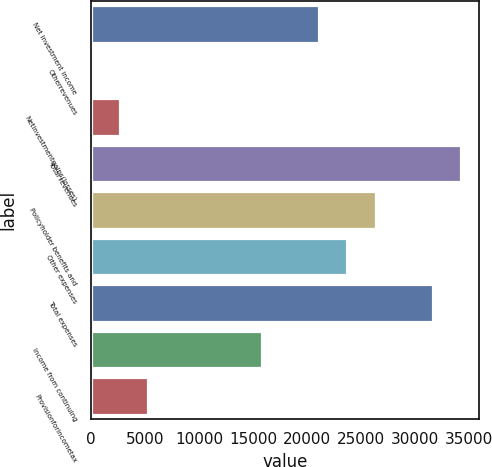Convert chart to OTSL. <chart><loc_0><loc_0><loc_500><loc_500><bar_chart><fcel>Net investment income<fcel>Otherrevenues<fcel>Netinvestmentgains(losses)<fcel>Total revenues<fcel>Policyholder benefits and<fcel>Other expenses<fcel>Total expenses<fcel>Income from continuing<fcel>Provisionforincometax<nl><fcel>21090.4<fcel>24<fcel>2657.3<fcel>34256.9<fcel>26357<fcel>23723.7<fcel>31623.6<fcel>15823.8<fcel>5290.6<nl></chart> 